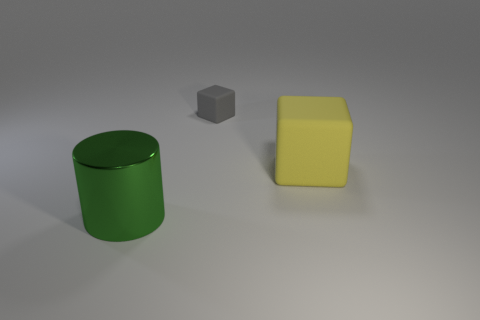Is there any other thing that has the same size as the gray thing?
Give a very brief answer. No. Are there any other things that are the same material as the green thing?
Make the answer very short. No. Are there an equal number of large green cylinders that are right of the large cylinder and small things?
Make the answer very short. No. What is the size of the thing that is on the left side of the big cube and right of the large green shiny cylinder?
Keep it short and to the point. Small. Is there anything else of the same color as the small matte cube?
Keep it short and to the point. No. What is the size of the thing in front of the matte block that is in front of the small matte object?
Offer a terse response. Large. What color is the thing that is in front of the tiny gray rubber thing and on the right side of the metal thing?
Provide a short and direct response. Yellow. What number of other objects are the same size as the cylinder?
Make the answer very short. 1. Does the gray thing have the same size as the matte block that is in front of the tiny rubber cube?
Keep it short and to the point. No. The rubber object that is the same size as the green metallic object is what color?
Ensure brevity in your answer.  Yellow. 